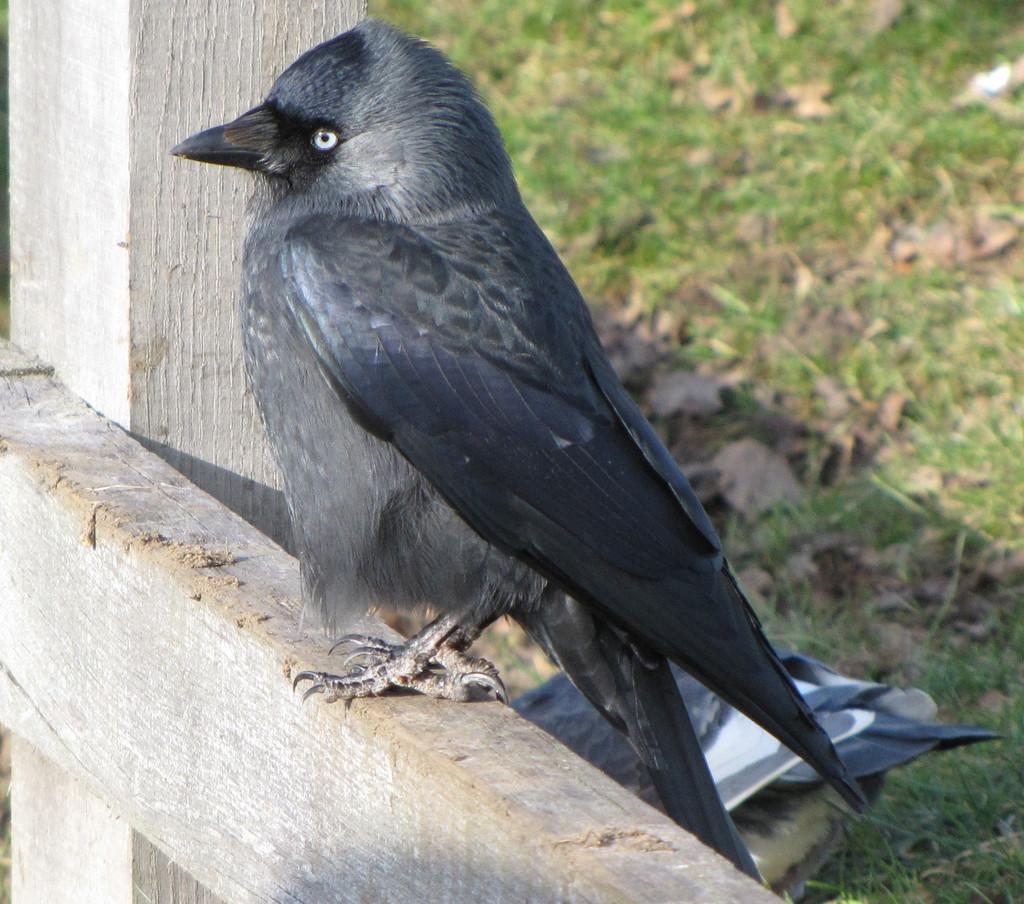What type of animal can be seen in the image? There is a bird in the image. What color is the bird? The bird is black in color. What other objects are visible in the image? There are wooden sticks and green grass in the image. What additional elements can be found in the image? Dried leaves are present in the image. What direction is the store located in the image? There is no store present in the image. 